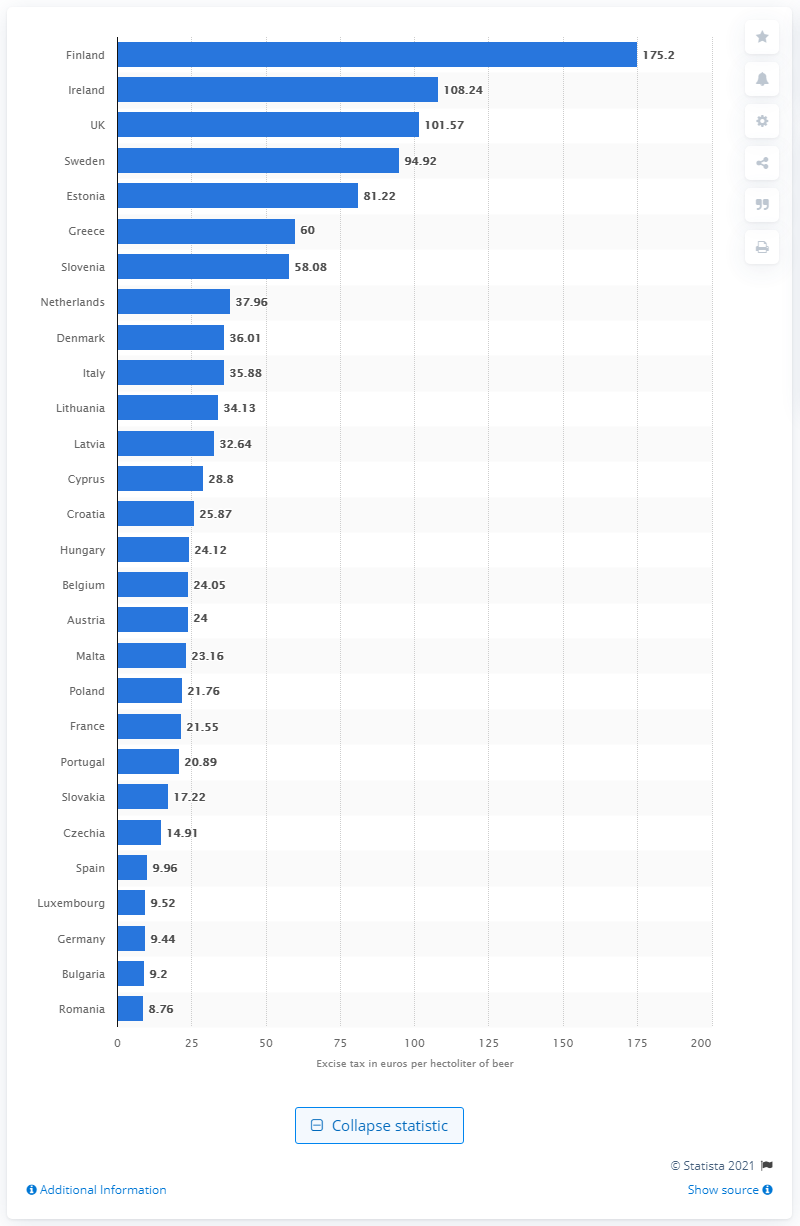Highlight a few significant elements in this photo. In 2019, Ireland had the highest excise tax on beer in the world. 